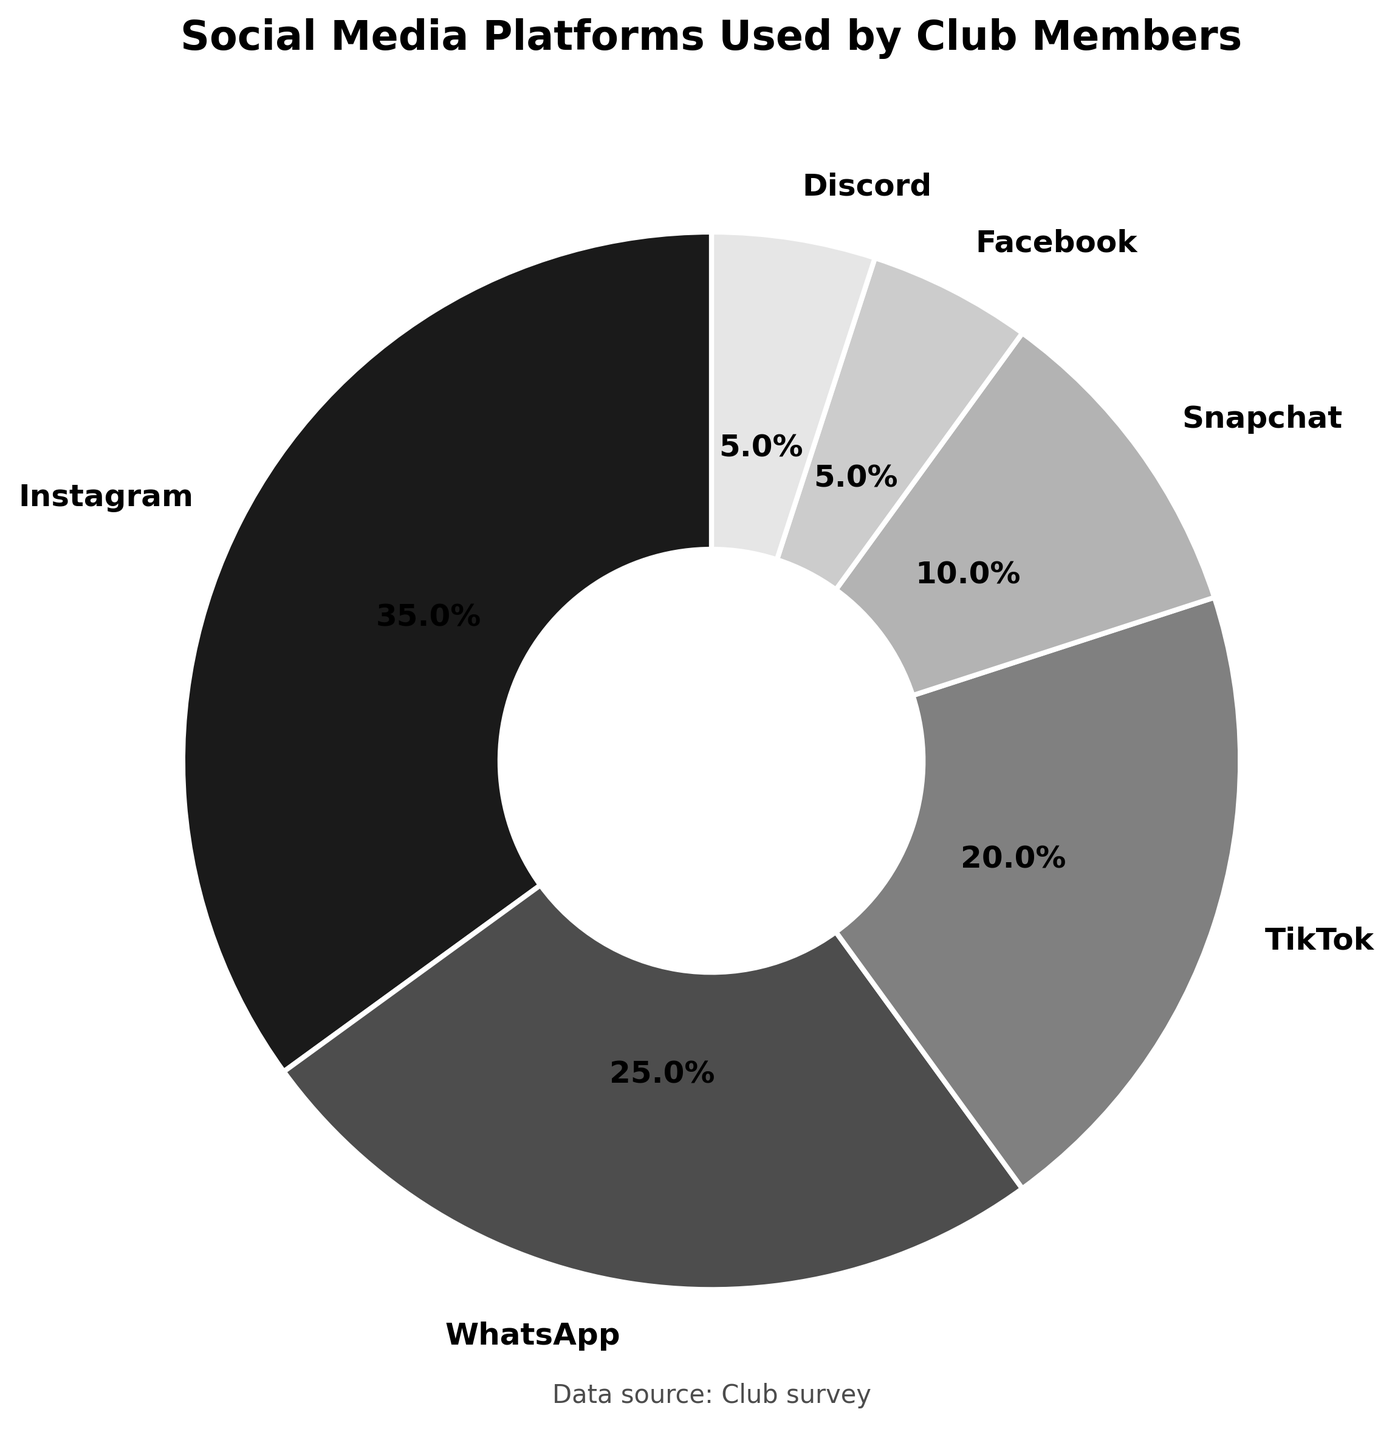What is the most used social media platform by club members? The figure shows that Instagram has the largest segment in the pie chart. By reading the labels, Instagram is at 35%.
Answer: Instagram What percentage of club members use TikTok? There is a segment in the pie chart labeled TikTok, and reading the percentage associated with this segment shows 20%.
Answer: 20% What is the combined percentage of club members using Facebook and Discord? The figure shows percentages for Facebook and Discord as 5% each. Adding these gives 5% + 5% = 10%.
Answer: 10% How does the usage of WhatsApp compare to Snapchat? WhatsApp has 25% while Snapchat has 10%. Viewing their sizes in the pie chart and their respective labels confirms this comparison, indicating WhatsApp usage is higher.
Answer: WhatsApp is used more What is the second least used social media platform by club members? By reading the percentages of each segment, Facebook and Discord both have 5%, which are the least. The next smallest percentage is Snapchat with 10%.
Answer: Snapchat Which social media platform is used by a quarter of the club members? A section labeled WhatsApp shows 25%. A quarter translates to 25% of the whole.
Answer: WhatsApp Which two platforms collectively make up more than 50% of the communication methods? Instagram (35%) and WhatsApp (25%) together make 60%. This cumulative percentage is above 50%.
Answer: Instagram and WhatsApp How is the pie chart labeled? The segments in the pie chart are labeled with the names and percentages of different social media platforms used.
Answer: With platform names and percentages If you combine the percentage of Instagram and TikTok, how much is it? Instagram accounts for 35% and TikTok accounts for 20%. Adding them gives 35% + 20% = 55%.
Answer: 55% What is the total percentage of club members using Instagram, TikTok, and Facebook? Instagram is 35%, TikTok is 20%, and Facebook is 5%. Adding these gives 35% + 20% + 5% = 60%.
Answer: 60% 